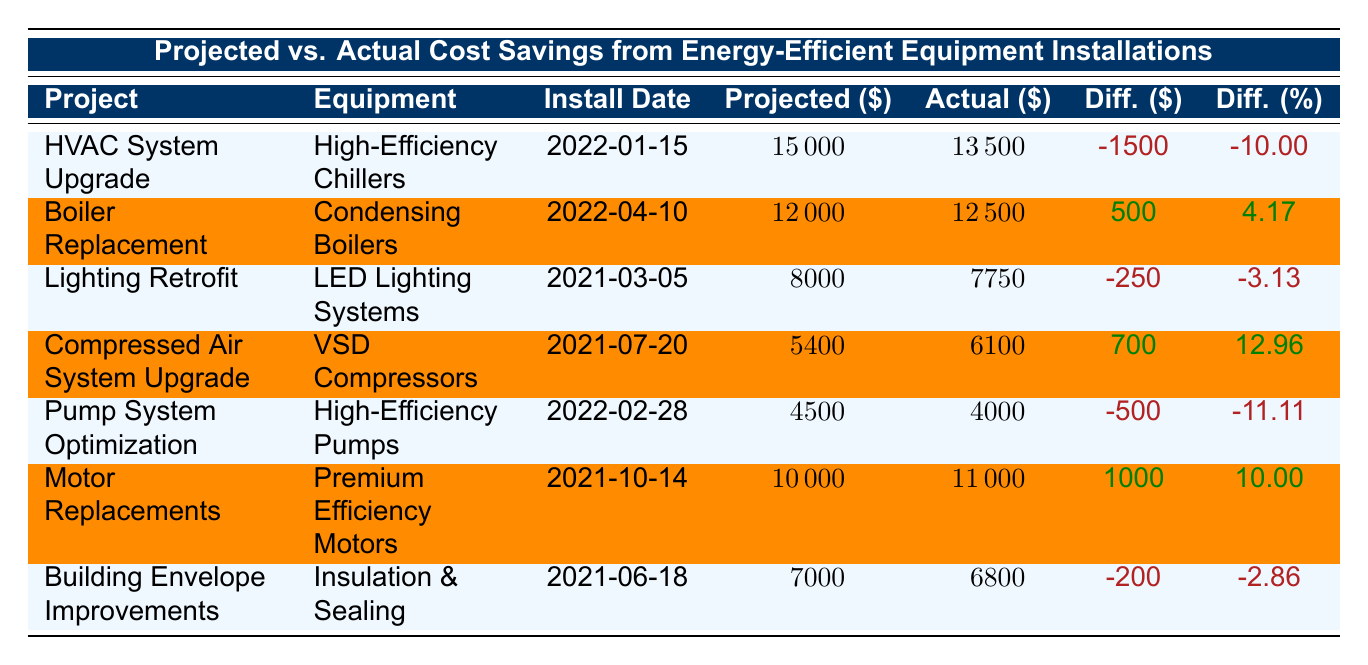What is the actual cost saving for the HVAC System Upgrade? The table shows that the actual cost saving for the HVAC System Upgrade project is listed under the "Actual" column, which indicates \$13,500.
Answer: 13500 Which project had the highest percentage of cost savings difference? To find this, I need to look at the "Diff. (%)" column. The maximum value is 12.96%, which corresponds to the Compressed Air System Upgrade project.
Answer: Compressed Air System Upgrade Was the actual cost saving for the Boiler Replacement project higher than the projected cost saving? For the Boiler Replacement project, the projected cost saving is \$12,000 and the actual cost saving is \$12,500. Since \$12,500 is greater than \$12,000, the statement is true.
Answer: Yes What is the total projected cost savings for all the projects combined? To find this, I sum the values under "Projected" column: 15000 + 12000 + 8000 + 5400 + 4500 + 10000 + 7000 =  60000.
Answer: 60000 Which project(s) had actual cost savings below projected cost savings? I need to examine the "Difference" column for negative values: HVAC System Upgrade, Lighting Retrofit, Pump System Optimization, and Building Envelope Improvements all have negative differences, indicating actual savings below projected.
Answer: HVAC System Upgrade, Lighting Retrofit, Pump System Optimization, Building Envelope Improvements What is the average actual cost savings across all projects? To calculate the average, sum the actual savings: 13500 + 12500 + 7750 + 6100 + 4000 + 11000 + 6800 = 60000, and divide by the number of projects, which is 7. So, 60000/7 = 8571.43.
Answer: 8571.43 Did any projects exceed their projected savings by more than \$1,000? Looking at the "Diff. (\$)" column, the only project that exceeded projected savings by more than \$1,000 is the Motor Replacements project, with a difference of \$1,000.
Answer: No 